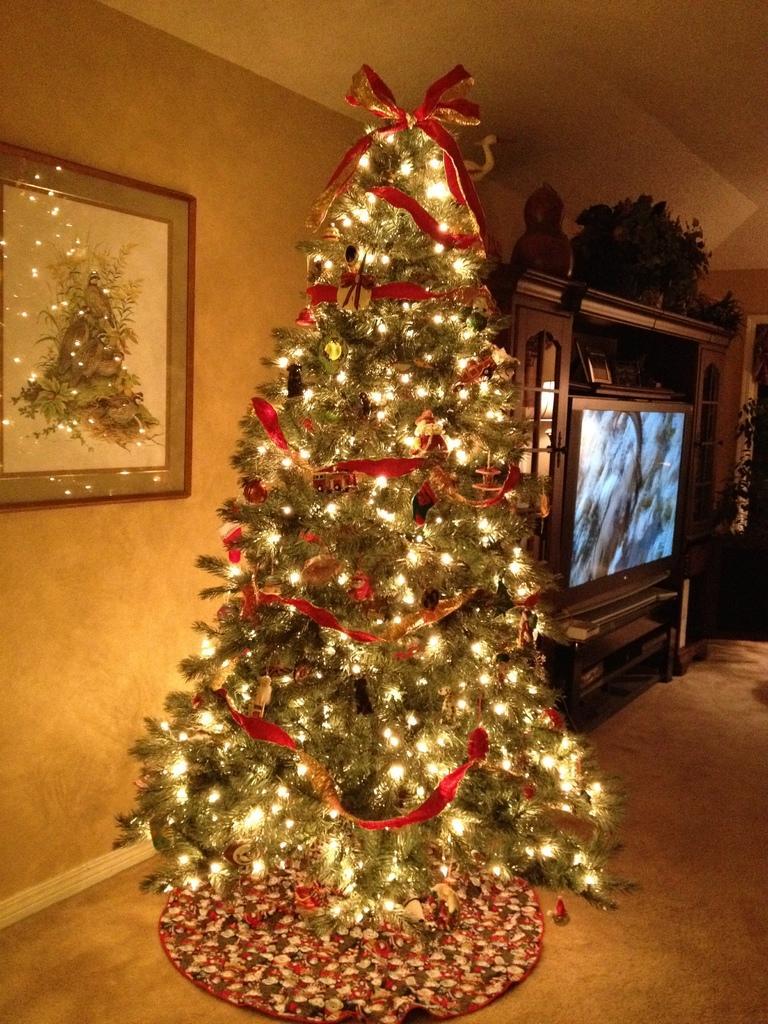Could you give a brief overview of what you see in this image? In the middle of the image we can see a christmas tree and lights, on the left side of the image we can see a frame on the wall, in the background we can see a television and few plants. 